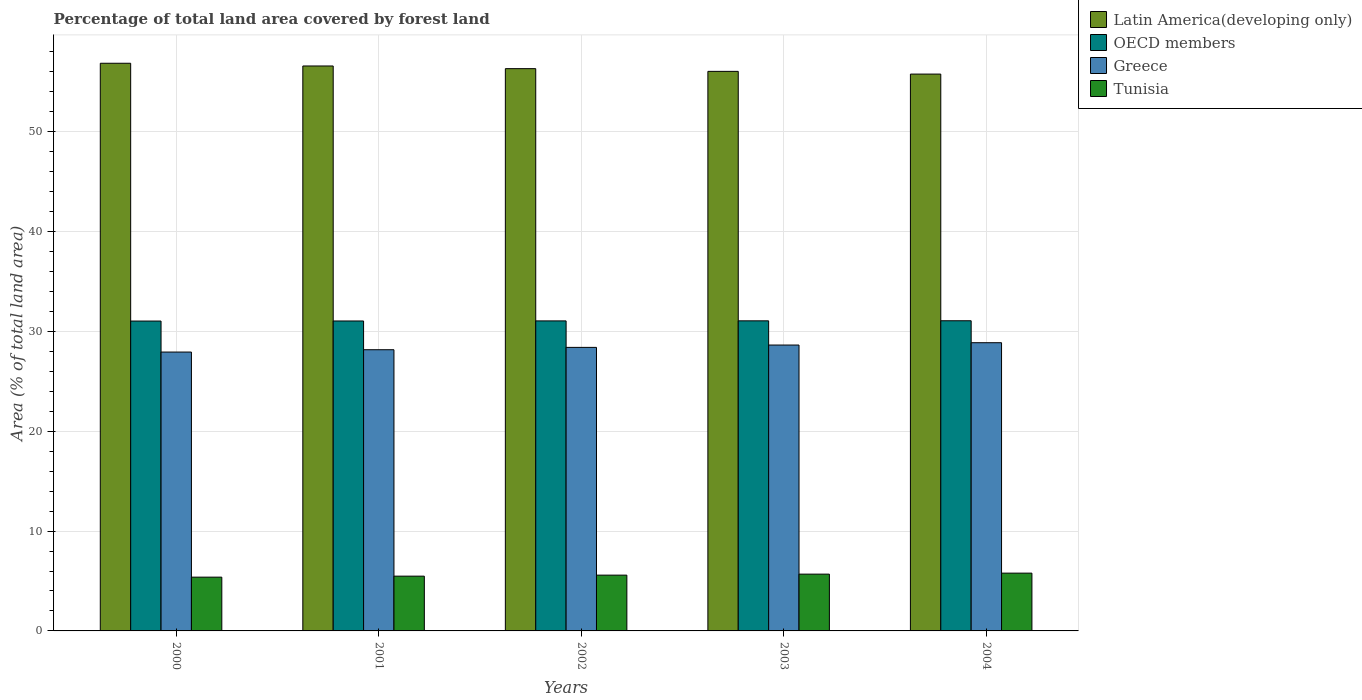How many different coloured bars are there?
Provide a short and direct response. 4. How many groups of bars are there?
Provide a succinct answer. 5. How many bars are there on the 3rd tick from the right?
Provide a short and direct response. 4. In how many cases, is the number of bars for a given year not equal to the number of legend labels?
Give a very brief answer. 0. What is the percentage of forest land in Greece in 2004?
Make the answer very short. 28.87. Across all years, what is the maximum percentage of forest land in Greece?
Your answer should be compact. 28.87. Across all years, what is the minimum percentage of forest land in Greece?
Provide a short and direct response. 27.94. In which year was the percentage of forest land in Greece maximum?
Keep it short and to the point. 2004. What is the total percentage of forest land in Greece in the graph?
Keep it short and to the point. 142.02. What is the difference between the percentage of forest land in Tunisia in 2003 and that in 2004?
Make the answer very short. -0.1. What is the difference between the percentage of forest land in Greece in 2001 and the percentage of forest land in OECD members in 2002?
Ensure brevity in your answer.  -2.89. What is the average percentage of forest land in Latin America(developing only) per year?
Provide a short and direct response. 56.33. In the year 2001, what is the difference between the percentage of forest land in Greece and percentage of forest land in OECD members?
Offer a very short reply. -2.88. In how many years, is the percentage of forest land in Latin America(developing only) greater than 30 %?
Make the answer very short. 5. What is the ratio of the percentage of forest land in Greece in 2002 to that in 2004?
Your response must be concise. 0.98. Is the percentage of forest land in Latin America(developing only) in 2000 less than that in 2004?
Your answer should be very brief. No. Is the difference between the percentage of forest land in Greece in 2000 and 2004 greater than the difference between the percentage of forest land in OECD members in 2000 and 2004?
Keep it short and to the point. No. What is the difference between the highest and the second highest percentage of forest land in OECD members?
Provide a succinct answer. 0.01. What is the difference between the highest and the lowest percentage of forest land in Greece?
Your response must be concise. 0.94. Is it the case that in every year, the sum of the percentage of forest land in Tunisia and percentage of forest land in Greece is greater than the sum of percentage of forest land in Latin America(developing only) and percentage of forest land in OECD members?
Keep it short and to the point. No. What does the 4th bar from the left in 2003 represents?
Give a very brief answer. Tunisia. How many bars are there?
Your answer should be very brief. 20. Are all the bars in the graph horizontal?
Provide a short and direct response. No. How many years are there in the graph?
Provide a succinct answer. 5. Does the graph contain any zero values?
Ensure brevity in your answer.  No. Where does the legend appear in the graph?
Make the answer very short. Top right. How are the legend labels stacked?
Your response must be concise. Vertical. What is the title of the graph?
Your response must be concise. Percentage of total land area covered by forest land. What is the label or title of the X-axis?
Keep it short and to the point. Years. What is the label or title of the Y-axis?
Give a very brief answer. Area (% of total land area). What is the Area (% of total land area) in Latin America(developing only) in 2000?
Offer a terse response. 56.87. What is the Area (% of total land area) of OECD members in 2000?
Ensure brevity in your answer.  31.04. What is the Area (% of total land area) in Greece in 2000?
Give a very brief answer. 27.94. What is the Area (% of total land area) in Tunisia in 2000?
Your answer should be compact. 5.39. What is the Area (% of total land area) of Latin America(developing only) in 2001?
Make the answer very short. 56.6. What is the Area (% of total land area) in OECD members in 2001?
Offer a very short reply. 31.05. What is the Area (% of total land area) of Greece in 2001?
Offer a terse response. 28.17. What is the Area (% of total land area) in Tunisia in 2001?
Your answer should be very brief. 5.49. What is the Area (% of total land area) in Latin America(developing only) in 2002?
Offer a very short reply. 56.33. What is the Area (% of total land area) in OECD members in 2002?
Keep it short and to the point. 31.06. What is the Area (% of total land area) in Greece in 2002?
Provide a short and direct response. 28.4. What is the Area (% of total land area) of Tunisia in 2002?
Keep it short and to the point. 5.59. What is the Area (% of total land area) in Latin America(developing only) in 2003?
Keep it short and to the point. 56.06. What is the Area (% of total land area) of OECD members in 2003?
Make the answer very short. 31.06. What is the Area (% of total land area) of Greece in 2003?
Offer a very short reply. 28.64. What is the Area (% of total land area) in Tunisia in 2003?
Provide a succinct answer. 5.69. What is the Area (% of total land area) in Latin America(developing only) in 2004?
Your response must be concise. 55.78. What is the Area (% of total land area) in OECD members in 2004?
Your answer should be very brief. 31.07. What is the Area (% of total land area) of Greece in 2004?
Provide a succinct answer. 28.87. What is the Area (% of total land area) in Tunisia in 2004?
Ensure brevity in your answer.  5.79. Across all years, what is the maximum Area (% of total land area) in Latin America(developing only)?
Provide a succinct answer. 56.87. Across all years, what is the maximum Area (% of total land area) in OECD members?
Your answer should be compact. 31.07. Across all years, what is the maximum Area (% of total land area) of Greece?
Your response must be concise. 28.87. Across all years, what is the maximum Area (% of total land area) in Tunisia?
Provide a succinct answer. 5.79. Across all years, what is the minimum Area (% of total land area) in Latin America(developing only)?
Keep it short and to the point. 55.78. Across all years, what is the minimum Area (% of total land area) in OECD members?
Your response must be concise. 31.04. Across all years, what is the minimum Area (% of total land area) in Greece?
Make the answer very short. 27.94. Across all years, what is the minimum Area (% of total land area) in Tunisia?
Provide a succinct answer. 5.39. What is the total Area (% of total land area) in Latin America(developing only) in the graph?
Offer a terse response. 281.63. What is the total Area (% of total land area) of OECD members in the graph?
Offer a terse response. 155.29. What is the total Area (% of total land area) of Greece in the graph?
Provide a succinct answer. 142.02. What is the total Area (% of total land area) of Tunisia in the graph?
Ensure brevity in your answer.  27.94. What is the difference between the Area (% of total land area) in Latin America(developing only) in 2000 and that in 2001?
Ensure brevity in your answer.  0.27. What is the difference between the Area (% of total land area) of OECD members in 2000 and that in 2001?
Keep it short and to the point. -0.01. What is the difference between the Area (% of total land area) of Greece in 2000 and that in 2001?
Provide a succinct answer. -0.23. What is the difference between the Area (% of total land area) in Tunisia in 2000 and that in 2001?
Your answer should be very brief. -0.1. What is the difference between the Area (% of total land area) of Latin America(developing only) in 2000 and that in 2002?
Offer a very short reply. 0.54. What is the difference between the Area (% of total land area) of OECD members in 2000 and that in 2002?
Give a very brief answer. -0.02. What is the difference between the Area (% of total land area) of Greece in 2000 and that in 2002?
Offer a very short reply. -0.47. What is the difference between the Area (% of total land area) in Tunisia in 2000 and that in 2002?
Offer a very short reply. -0.2. What is the difference between the Area (% of total land area) of Latin America(developing only) in 2000 and that in 2003?
Offer a very short reply. 0.81. What is the difference between the Area (% of total land area) of OECD members in 2000 and that in 2003?
Provide a succinct answer. -0.02. What is the difference between the Area (% of total land area) of Greece in 2000 and that in 2003?
Your answer should be very brief. -0.7. What is the difference between the Area (% of total land area) of Tunisia in 2000 and that in 2003?
Provide a short and direct response. -0.3. What is the difference between the Area (% of total land area) in Latin America(developing only) in 2000 and that in 2004?
Offer a very short reply. 1.08. What is the difference between the Area (% of total land area) in OECD members in 2000 and that in 2004?
Your answer should be very brief. -0.03. What is the difference between the Area (% of total land area) of Greece in 2000 and that in 2004?
Give a very brief answer. -0.94. What is the difference between the Area (% of total land area) in Tunisia in 2000 and that in 2004?
Provide a short and direct response. -0.4. What is the difference between the Area (% of total land area) in Latin America(developing only) in 2001 and that in 2002?
Make the answer very short. 0.27. What is the difference between the Area (% of total land area) in OECD members in 2001 and that in 2002?
Your answer should be very brief. -0.01. What is the difference between the Area (% of total land area) of Greece in 2001 and that in 2002?
Your response must be concise. -0.23. What is the difference between the Area (% of total land area) of Tunisia in 2001 and that in 2002?
Make the answer very short. -0.1. What is the difference between the Area (% of total land area) in Latin America(developing only) in 2001 and that in 2003?
Make the answer very short. 0.54. What is the difference between the Area (% of total land area) of OECD members in 2001 and that in 2003?
Offer a very short reply. -0.01. What is the difference between the Area (% of total land area) of Greece in 2001 and that in 2003?
Make the answer very short. -0.47. What is the difference between the Area (% of total land area) of Tunisia in 2001 and that in 2003?
Ensure brevity in your answer.  -0.2. What is the difference between the Area (% of total land area) in Latin America(developing only) in 2001 and that in 2004?
Offer a terse response. 0.81. What is the difference between the Area (% of total land area) of OECD members in 2001 and that in 2004?
Ensure brevity in your answer.  -0.02. What is the difference between the Area (% of total land area) in Greece in 2001 and that in 2004?
Your answer should be compact. -0.7. What is the difference between the Area (% of total land area) in Tunisia in 2001 and that in 2004?
Offer a terse response. -0.3. What is the difference between the Area (% of total land area) of Latin America(developing only) in 2002 and that in 2003?
Make the answer very short. 0.27. What is the difference between the Area (% of total land area) in OECD members in 2002 and that in 2003?
Your answer should be very brief. -0.01. What is the difference between the Area (% of total land area) in Greece in 2002 and that in 2003?
Make the answer very short. -0.23. What is the difference between the Area (% of total land area) in Tunisia in 2002 and that in 2003?
Give a very brief answer. -0.1. What is the difference between the Area (% of total land area) in Latin America(developing only) in 2002 and that in 2004?
Your response must be concise. 0.54. What is the difference between the Area (% of total land area) of OECD members in 2002 and that in 2004?
Provide a short and direct response. -0.02. What is the difference between the Area (% of total land area) in Greece in 2002 and that in 2004?
Provide a succinct answer. -0.47. What is the difference between the Area (% of total land area) of Tunisia in 2002 and that in 2004?
Offer a very short reply. -0.2. What is the difference between the Area (% of total land area) in Latin America(developing only) in 2003 and that in 2004?
Keep it short and to the point. 0.27. What is the difference between the Area (% of total land area) in OECD members in 2003 and that in 2004?
Your answer should be compact. -0.01. What is the difference between the Area (% of total land area) of Greece in 2003 and that in 2004?
Keep it short and to the point. -0.23. What is the difference between the Area (% of total land area) in Tunisia in 2003 and that in 2004?
Provide a short and direct response. -0.1. What is the difference between the Area (% of total land area) of Latin America(developing only) in 2000 and the Area (% of total land area) of OECD members in 2001?
Your answer should be very brief. 25.82. What is the difference between the Area (% of total land area) in Latin America(developing only) in 2000 and the Area (% of total land area) in Greece in 2001?
Ensure brevity in your answer.  28.7. What is the difference between the Area (% of total land area) of Latin America(developing only) in 2000 and the Area (% of total land area) of Tunisia in 2001?
Your answer should be very brief. 51.38. What is the difference between the Area (% of total land area) in OECD members in 2000 and the Area (% of total land area) in Greece in 2001?
Provide a succinct answer. 2.87. What is the difference between the Area (% of total land area) in OECD members in 2000 and the Area (% of total land area) in Tunisia in 2001?
Your answer should be compact. 25.55. What is the difference between the Area (% of total land area) of Greece in 2000 and the Area (% of total land area) of Tunisia in 2001?
Your answer should be very brief. 22.45. What is the difference between the Area (% of total land area) of Latin America(developing only) in 2000 and the Area (% of total land area) of OECD members in 2002?
Your answer should be compact. 25.81. What is the difference between the Area (% of total land area) in Latin America(developing only) in 2000 and the Area (% of total land area) in Greece in 2002?
Offer a terse response. 28.46. What is the difference between the Area (% of total land area) of Latin America(developing only) in 2000 and the Area (% of total land area) of Tunisia in 2002?
Provide a short and direct response. 51.28. What is the difference between the Area (% of total land area) of OECD members in 2000 and the Area (% of total land area) of Greece in 2002?
Your response must be concise. 2.64. What is the difference between the Area (% of total land area) of OECD members in 2000 and the Area (% of total land area) of Tunisia in 2002?
Your answer should be compact. 25.45. What is the difference between the Area (% of total land area) of Greece in 2000 and the Area (% of total land area) of Tunisia in 2002?
Make the answer very short. 22.35. What is the difference between the Area (% of total land area) in Latin America(developing only) in 2000 and the Area (% of total land area) in OECD members in 2003?
Keep it short and to the point. 25.8. What is the difference between the Area (% of total land area) in Latin America(developing only) in 2000 and the Area (% of total land area) in Greece in 2003?
Keep it short and to the point. 28.23. What is the difference between the Area (% of total land area) of Latin America(developing only) in 2000 and the Area (% of total land area) of Tunisia in 2003?
Ensure brevity in your answer.  51.18. What is the difference between the Area (% of total land area) in OECD members in 2000 and the Area (% of total land area) in Greece in 2003?
Your answer should be very brief. 2.4. What is the difference between the Area (% of total land area) in OECD members in 2000 and the Area (% of total land area) in Tunisia in 2003?
Keep it short and to the point. 25.35. What is the difference between the Area (% of total land area) in Greece in 2000 and the Area (% of total land area) in Tunisia in 2003?
Offer a very short reply. 22.25. What is the difference between the Area (% of total land area) of Latin America(developing only) in 2000 and the Area (% of total land area) of OECD members in 2004?
Make the answer very short. 25.8. What is the difference between the Area (% of total land area) in Latin America(developing only) in 2000 and the Area (% of total land area) in Greece in 2004?
Provide a short and direct response. 28. What is the difference between the Area (% of total land area) in Latin America(developing only) in 2000 and the Area (% of total land area) in Tunisia in 2004?
Your answer should be compact. 51.08. What is the difference between the Area (% of total land area) of OECD members in 2000 and the Area (% of total land area) of Greece in 2004?
Your answer should be compact. 2.17. What is the difference between the Area (% of total land area) of OECD members in 2000 and the Area (% of total land area) of Tunisia in 2004?
Give a very brief answer. 25.25. What is the difference between the Area (% of total land area) in Greece in 2000 and the Area (% of total land area) in Tunisia in 2004?
Offer a terse response. 22.15. What is the difference between the Area (% of total land area) of Latin America(developing only) in 2001 and the Area (% of total land area) of OECD members in 2002?
Ensure brevity in your answer.  25.54. What is the difference between the Area (% of total land area) in Latin America(developing only) in 2001 and the Area (% of total land area) in Greece in 2002?
Make the answer very short. 28.19. What is the difference between the Area (% of total land area) of Latin America(developing only) in 2001 and the Area (% of total land area) of Tunisia in 2002?
Ensure brevity in your answer.  51.01. What is the difference between the Area (% of total land area) in OECD members in 2001 and the Area (% of total land area) in Greece in 2002?
Offer a very short reply. 2.65. What is the difference between the Area (% of total land area) in OECD members in 2001 and the Area (% of total land area) in Tunisia in 2002?
Keep it short and to the point. 25.46. What is the difference between the Area (% of total land area) of Greece in 2001 and the Area (% of total land area) of Tunisia in 2002?
Your answer should be compact. 22.58. What is the difference between the Area (% of total land area) in Latin America(developing only) in 2001 and the Area (% of total land area) in OECD members in 2003?
Your answer should be compact. 25.53. What is the difference between the Area (% of total land area) of Latin America(developing only) in 2001 and the Area (% of total land area) of Greece in 2003?
Provide a short and direct response. 27.96. What is the difference between the Area (% of total land area) in Latin America(developing only) in 2001 and the Area (% of total land area) in Tunisia in 2003?
Give a very brief answer. 50.91. What is the difference between the Area (% of total land area) in OECD members in 2001 and the Area (% of total land area) in Greece in 2003?
Ensure brevity in your answer.  2.41. What is the difference between the Area (% of total land area) in OECD members in 2001 and the Area (% of total land area) in Tunisia in 2003?
Provide a succinct answer. 25.36. What is the difference between the Area (% of total land area) in Greece in 2001 and the Area (% of total land area) in Tunisia in 2003?
Make the answer very short. 22.48. What is the difference between the Area (% of total land area) of Latin America(developing only) in 2001 and the Area (% of total land area) of OECD members in 2004?
Provide a short and direct response. 25.52. What is the difference between the Area (% of total land area) in Latin America(developing only) in 2001 and the Area (% of total land area) in Greece in 2004?
Provide a short and direct response. 27.72. What is the difference between the Area (% of total land area) in Latin America(developing only) in 2001 and the Area (% of total land area) in Tunisia in 2004?
Make the answer very short. 50.81. What is the difference between the Area (% of total land area) in OECD members in 2001 and the Area (% of total land area) in Greece in 2004?
Keep it short and to the point. 2.18. What is the difference between the Area (% of total land area) of OECD members in 2001 and the Area (% of total land area) of Tunisia in 2004?
Ensure brevity in your answer.  25.26. What is the difference between the Area (% of total land area) in Greece in 2001 and the Area (% of total land area) in Tunisia in 2004?
Offer a terse response. 22.38. What is the difference between the Area (% of total land area) of Latin America(developing only) in 2002 and the Area (% of total land area) of OECD members in 2003?
Ensure brevity in your answer.  25.26. What is the difference between the Area (% of total land area) in Latin America(developing only) in 2002 and the Area (% of total land area) in Greece in 2003?
Make the answer very short. 27.69. What is the difference between the Area (% of total land area) in Latin America(developing only) in 2002 and the Area (% of total land area) in Tunisia in 2003?
Make the answer very short. 50.64. What is the difference between the Area (% of total land area) in OECD members in 2002 and the Area (% of total land area) in Greece in 2003?
Your answer should be very brief. 2.42. What is the difference between the Area (% of total land area) in OECD members in 2002 and the Area (% of total land area) in Tunisia in 2003?
Give a very brief answer. 25.37. What is the difference between the Area (% of total land area) of Greece in 2002 and the Area (% of total land area) of Tunisia in 2003?
Offer a terse response. 22.72. What is the difference between the Area (% of total land area) of Latin America(developing only) in 2002 and the Area (% of total land area) of OECD members in 2004?
Your answer should be very brief. 25.26. What is the difference between the Area (% of total land area) in Latin America(developing only) in 2002 and the Area (% of total land area) in Greece in 2004?
Offer a terse response. 27.45. What is the difference between the Area (% of total land area) of Latin America(developing only) in 2002 and the Area (% of total land area) of Tunisia in 2004?
Give a very brief answer. 50.54. What is the difference between the Area (% of total land area) of OECD members in 2002 and the Area (% of total land area) of Greece in 2004?
Make the answer very short. 2.18. What is the difference between the Area (% of total land area) of OECD members in 2002 and the Area (% of total land area) of Tunisia in 2004?
Ensure brevity in your answer.  25.27. What is the difference between the Area (% of total land area) of Greece in 2002 and the Area (% of total land area) of Tunisia in 2004?
Your answer should be compact. 22.62. What is the difference between the Area (% of total land area) in Latin America(developing only) in 2003 and the Area (% of total land area) in OECD members in 2004?
Your response must be concise. 24.98. What is the difference between the Area (% of total land area) of Latin America(developing only) in 2003 and the Area (% of total land area) of Greece in 2004?
Provide a succinct answer. 27.18. What is the difference between the Area (% of total land area) of Latin America(developing only) in 2003 and the Area (% of total land area) of Tunisia in 2004?
Your answer should be compact. 50.27. What is the difference between the Area (% of total land area) in OECD members in 2003 and the Area (% of total land area) in Greece in 2004?
Your answer should be compact. 2.19. What is the difference between the Area (% of total land area) of OECD members in 2003 and the Area (% of total land area) of Tunisia in 2004?
Keep it short and to the point. 25.28. What is the difference between the Area (% of total land area) in Greece in 2003 and the Area (% of total land area) in Tunisia in 2004?
Keep it short and to the point. 22.85. What is the average Area (% of total land area) in Latin America(developing only) per year?
Keep it short and to the point. 56.33. What is the average Area (% of total land area) in OECD members per year?
Provide a short and direct response. 31.06. What is the average Area (% of total land area) in Greece per year?
Ensure brevity in your answer.  28.41. What is the average Area (% of total land area) of Tunisia per year?
Your answer should be very brief. 5.59. In the year 2000, what is the difference between the Area (% of total land area) in Latin America(developing only) and Area (% of total land area) in OECD members?
Keep it short and to the point. 25.83. In the year 2000, what is the difference between the Area (% of total land area) of Latin America(developing only) and Area (% of total land area) of Greece?
Your response must be concise. 28.93. In the year 2000, what is the difference between the Area (% of total land area) of Latin America(developing only) and Area (% of total land area) of Tunisia?
Keep it short and to the point. 51.48. In the year 2000, what is the difference between the Area (% of total land area) of OECD members and Area (% of total land area) of Greece?
Your answer should be very brief. 3.11. In the year 2000, what is the difference between the Area (% of total land area) in OECD members and Area (% of total land area) in Tunisia?
Your response must be concise. 25.65. In the year 2000, what is the difference between the Area (% of total land area) of Greece and Area (% of total land area) of Tunisia?
Your answer should be very brief. 22.55. In the year 2001, what is the difference between the Area (% of total land area) of Latin America(developing only) and Area (% of total land area) of OECD members?
Make the answer very short. 25.55. In the year 2001, what is the difference between the Area (% of total land area) in Latin America(developing only) and Area (% of total land area) in Greece?
Your answer should be very brief. 28.43. In the year 2001, what is the difference between the Area (% of total land area) of Latin America(developing only) and Area (% of total land area) of Tunisia?
Offer a very short reply. 51.11. In the year 2001, what is the difference between the Area (% of total land area) in OECD members and Area (% of total land area) in Greece?
Make the answer very short. 2.88. In the year 2001, what is the difference between the Area (% of total land area) in OECD members and Area (% of total land area) in Tunisia?
Keep it short and to the point. 25.56. In the year 2001, what is the difference between the Area (% of total land area) in Greece and Area (% of total land area) in Tunisia?
Ensure brevity in your answer.  22.68. In the year 2002, what is the difference between the Area (% of total land area) in Latin America(developing only) and Area (% of total land area) in OECD members?
Offer a very short reply. 25.27. In the year 2002, what is the difference between the Area (% of total land area) in Latin America(developing only) and Area (% of total land area) in Greece?
Give a very brief answer. 27.92. In the year 2002, what is the difference between the Area (% of total land area) of Latin America(developing only) and Area (% of total land area) of Tunisia?
Your response must be concise. 50.74. In the year 2002, what is the difference between the Area (% of total land area) of OECD members and Area (% of total land area) of Greece?
Give a very brief answer. 2.65. In the year 2002, what is the difference between the Area (% of total land area) of OECD members and Area (% of total land area) of Tunisia?
Provide a short and direct response. 25.47. In the year 2002, what is the difference between the Area (% of total land area) in Greece and Area (% of total land area) in Tunisia?
Make the answer very short. 22.82. In the year 2003, what is the difference between the Area (% of total land area) in Latin America(developing only) and Area (% of total land area) in OECD members?
Make the answer very short. 24.99. In the year 2003, what is the difference between the Area (% of total land area) of Latin America(developing only) and Area (% of total land area) of Greece?
Your answer should be compact. 27.42. In the year 2003, what is the difference between the Area (% of total land area) in Latin America(developing only) and Area (% of total land area) in Tunisia?
Ensure brevity in your answer.  50.37. In the year 2003, what is the difference between the Area (% of total land area) of OECD members and Area (% of total land area) of Greece?
Your answer should be compact. 2.43. In the year 2003, what is the difference between the Area (% of total land area) of OECD members and Area (% of total land area) of Tunisia?
Your answer should be compact. 25.38. In the year 2003, what is the difference between the Area (% of total land area) in Greece and Area (% of total land area) in Tunisia?
Ensure brevity in your answer.  22.95. In the year 2004, what is the difference between the Area (% of total land area) of Latin America(developing only) and Area (% of total land area) of OECD members?
Your response must be concise. 24.71. In the year 2004, what is the difference between the Area (% of total land area) of Latin America(developing only) and Area (% of total land area) of Greece?
Make the answer very short. 26.91. In the year 2004, what is the difference between the Area (% of total land area) in Latin America(developing only) and Area (% of total land area) in Tunisia?
Provide a succinct answer. 50. In the year 2004, what is the difference between the Area (% of total land area) in OECD members and Area (% of total land area) in Greece?
Provide a succinct answer. 2.2. In the year 2004, what is the difference between the Area (% of total land area) of OECD members and Area (% of total land area) of Tunisia?
Ensure brevity in your answer.  25.28. In the year 2004, what is the difference between the Area (% of total land area) in Greece and Area (% of total land area) in Tunisia?
Give a very brief answer. 23.08. What is the ratio of the Area (% of total land area) in Latin America(developing only) in 2000 to that in 2001?
Your answer should be compact. 1. What is the ratio of the Area (% of total land area) of OECD members in 2000 to that in 2001?
Provide a short and direct response. 1. What is the ratio of the Area (% of total land area) of Greece in 2000 to that in 2001?
Offer a terse response. 0.99. What is the ratio of the Area (% of total land area) in Tunisia in 2000 to that in 2001?
Give a very brief answer. 0.98. What is the ratio of the Area (% of total land area) in Latin America(developing only) in 2000 to that in 2002?
Your answer should be compact. 1.01. What is the ratio of the Area (% of total land area) in OECD members in 2000 to that in 2002?
Your answer should be very brief. 1. What is the ratio of the Area (% of total land area) in Greece in 2000 to that in 2002?
Offer a terse response. 0.98. What is the ratio of the Area (% of total land area) of Tunisia in 2000 to that in 2002?
Give a very brief answer. 0.96. What is the ratio of the Area (% of total land area) of Latin America(developing only) in 2000 to that in 2003?
Give a very brief answer. 1.01. What is the ratio of the Area (% of total land area) of Greece in 2000 to that in 2003?
Give a very brief answer. 0.98. What is the ratio of the Area (% of total land area) of Tunisia in 2000 to that in 2003?
Offer a terse response. 0.95. What is the ratio of the Area (% of total land area) in Latin America(developing only) in 2000 to that in 2004?
Give a very brief answer. 1.02. What is the ratio of the Area (% of total land area) of Greece in 2000 to that in 2004?
Provide a short and direct response. 0.97. What is the ratio of the Area (% of total land area) in Tunisia in 2000 to that in 2004?
Offer a very short reply. 0.93. What is the ratio of the Area (% of total land area) of Latin America(developing only) in 2001 to that in 2003?
Provide a succinct answer. 1.01. What is the ratio of the Area (% of total land area) of Greece in 2001 to that in 2003?
Keep it short and to the point. 0.98. What is the ratio of the Area (% of total land area) in Tunisia in 2001 to that in 2003?
Your response must be concise. 0.96. What is the ratio of the Area (% of total land area) in Latin America(developing only) in 2001 to that in 2004?
Give a very brief answer. 1.01. What is the ratio of the Area (% of total land area) in OECD members in 2001 to that in 2004?
Provide a succinct answer. 1. What is the ratio of the Area (% of total land area) of Greece in 2001 to that in 2004?
Your answer should be compact. 0.98. What is the ratio of the Area (% of total land area) in Tunisia in 2001 to that in 2004?
Your answer should be compact. 0.95. What is the ratio of the Area (% of total land area) in Tunisia in 2002 to that in 2003?
Your answer should be very brief. 0.98. What is the ratio of the Area (% of total land area) of Latin America(developing only) in 2002 to that in 2004?
Keep it short and to the point. 1.01. What is the ratio of the Area (% of total land area) of Greece in 2002 to that in 2004?
Provide a short and direct response. 0.98. What is the ratio of the Area (% of total land area) in Tunisia in 2002 to that in 2004?
Make the answer very short. 0.97. What is the ratio of the Area (% of total land area) of Greece in 2003 to that in 2004?
Your answer should be very brief. 0.99. What is the ratio of the Area (% of total land area) in Tunisia in 2003 to that in 2004?
Your answer should be very brief. 0.98. What is the difference between the highest and the second highest Area (% of total land area) of Latin America(developing only)?
Provide a succinct answer. 0.27. What is the difference between the highest and the second highest Area (% of total land area) of OECD members?
Provide a short and direct response. 0.01. What is the difference between the highest and the second highest Area (% of total land area) in Greece?
Your answer should be very brief. 0.23. What is the difference between the highest and the second highest Area (% of total land area) of Tunisia?
Keep it short and to the point. 0.1. What is the difference between the highest and the lowest Area (% of total land area) of Latin America(developing only)?
Provide a succinct answer. 1.08. What is the difference between the highest and the lowest Area (% of total land area) in OECD members?
Provide a succinct answer. 0.03. What is the difference between the highest and the lowest Area (% of total land area) of Greece?
Ensure brevity in your answer.  0.94. What is the difference between the highest and the lowest Area (% of total land area) of Tunisia?
Provide a short and direct response. 0.4. 